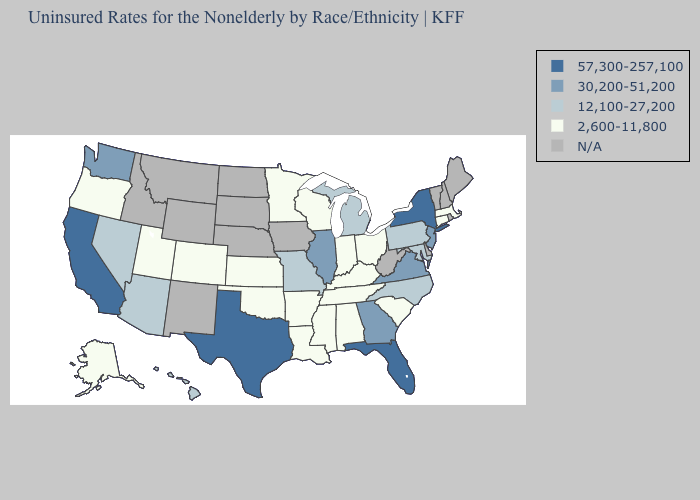Among the states that border Indiana , which have the highest value?
Write a very short answer. Illinois. What is the lowest value in the MidWest?
Concise answer only. 2,600-11,800. What is the value of Kentucky?
Be succinct. 2,600-11,800. Name the states that have a value in the range 30,200-51,200?
Concise answer only. Georgia, Illinois, New Jersey, Virginia, Washington. What is the highest value in the West ?
Give a very brief answer. 57,300-257,100. Is the legend a continuous bar?
Give a very brief answer. No. Name the states that have a value in the range 30,200-51,200?
Concise answer only. Georgia, Illinois, New Jersey, Virginia, Washington. Is the legend a continuous bar?
Write a very short answer. No. Among the states that border Georgia , which have the lowest value?
Quick response, please. Alabama, South Carolina, Tennessee. Among the states that border North Carolina , which have the lowest value?
Give a very brief answer. South Carolina, Tennessee. Does Wisconsin have the highest value in the MidWest?
Concise answer only. No. Is the legend a continuous bar?
Keep it brief. No. What is the value of Delaware?
Short answer required. N/A. What is the lowest value in the USA?
Answer briefly. 2,600-11,800. Among the states that border Utah , does Colorado have the highest value?
Keep it brief. No. 